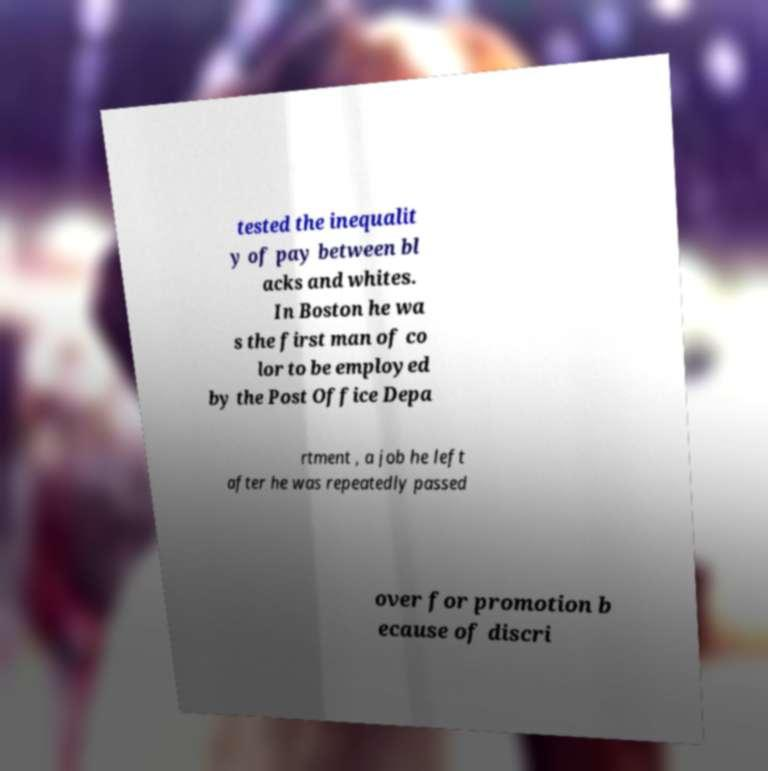Could you extract and type out the text from this image? tested the inequalit y of pay between bl acks and whites. In Boston he wa s the first man of co lor to be employed by the Post Office Depa rtment , a job he left after he was repeatedly passed over for promotion b ecause of discri 